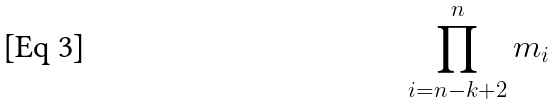<formula> <loc_0><loc_0><loc_500><loc_500>\prod _ { i = n - k + 2 } ^ { n } m _ { i }</formula> 